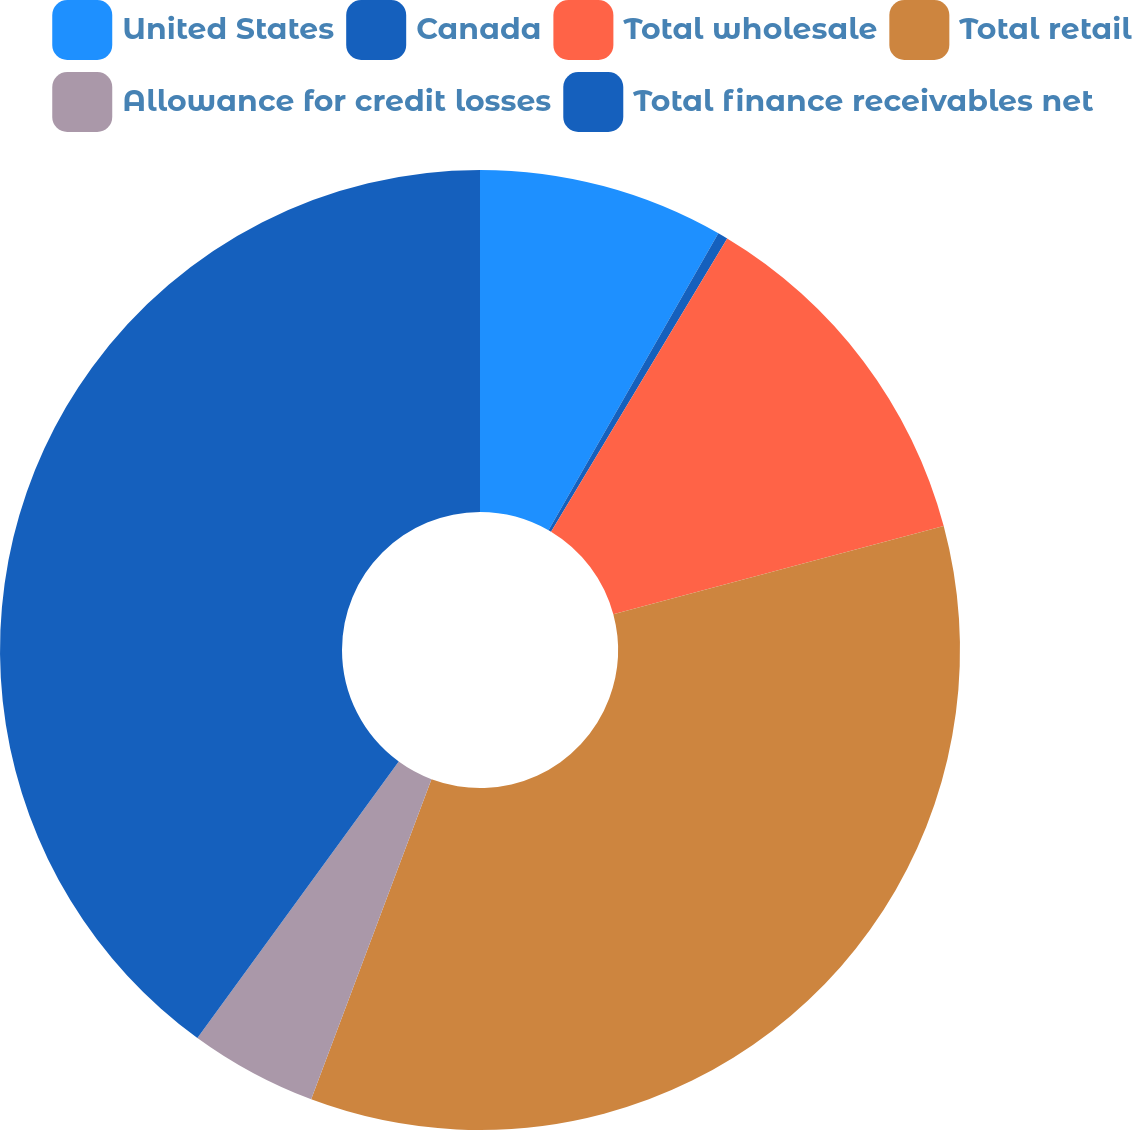<chart> <loc_0><loc_0><loc_500><loc_500><pie_chart><fcel>United States<fcel>Canada<fcel>Total wholesale<fcel>Total retail<fcel>Allowance for credit losses<fcel>Total finance receivables net<nl><fcel>8.27%<fcel>0.34%<fcel>12.23%<fcel>34.88%<fcel>4.3%<fcel>39.98%<nl></chart> 